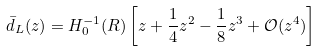Convert formula to latex. <formula><loc_0><loc_0><loc_500><loc_500>\bar { d } _ { L } ( z ) = H _ { 0 } ^ { - 1 } ( R ) \left [ z + \frac { 1 } { 4 } z ^ { 2 } - \frac { 1 } { 8 } z ^ { 3 } + \mathcal { O } ( z ^ { 4 } ) \right ]</formula> 